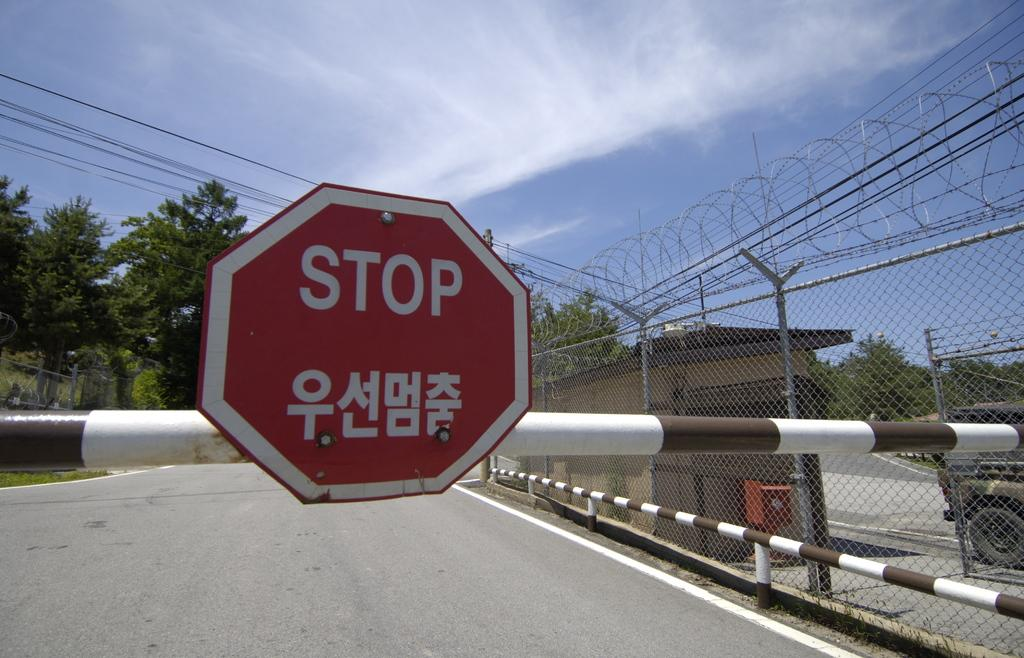What is the main object in the image? There is a signboard in the image. What type of natural elements can be seen in the image? There are trees in the image. What type of barrier is present in the image? There is a fence in the image. What mode of transportation can be seen in the image? There is a vehicle on the road in the image. What can be seen in the background of the image? The sky with clouds is visible in the background of the image. What type of art can be seen on the quince in the image? There is no quince or art present in the image. What type of oatmeal is being served in the image? There is no oatmeal present in the image. 